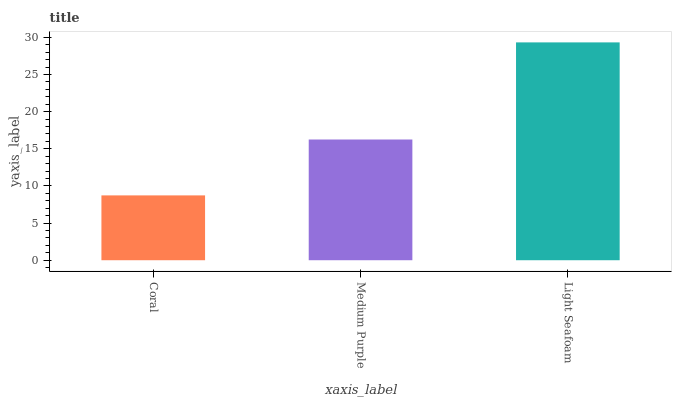Is Medium Purple the minimum?
Answer yes or no. No. Is Medium Purple the maximum?
Answer yes or no. No. Is Medium Purple greater than Coral?
Answer yes or no. Yes. Is Coral less than Medium Purple?
Answer yes or no. Yes. Is Coral greater than Medium Purple?
Answer yes or no. No. Is Medium Purple less than Coral?
Answer yes or no. No. Is Medium Purple the high median?
Answer yes or no. Yes. Is Medium Purple the low median?
Answer yes or no. Yes. Is Coral the high median?
Answer yes or no. No. Is Light Seafoam the low median?
Answer yes or no. No. 